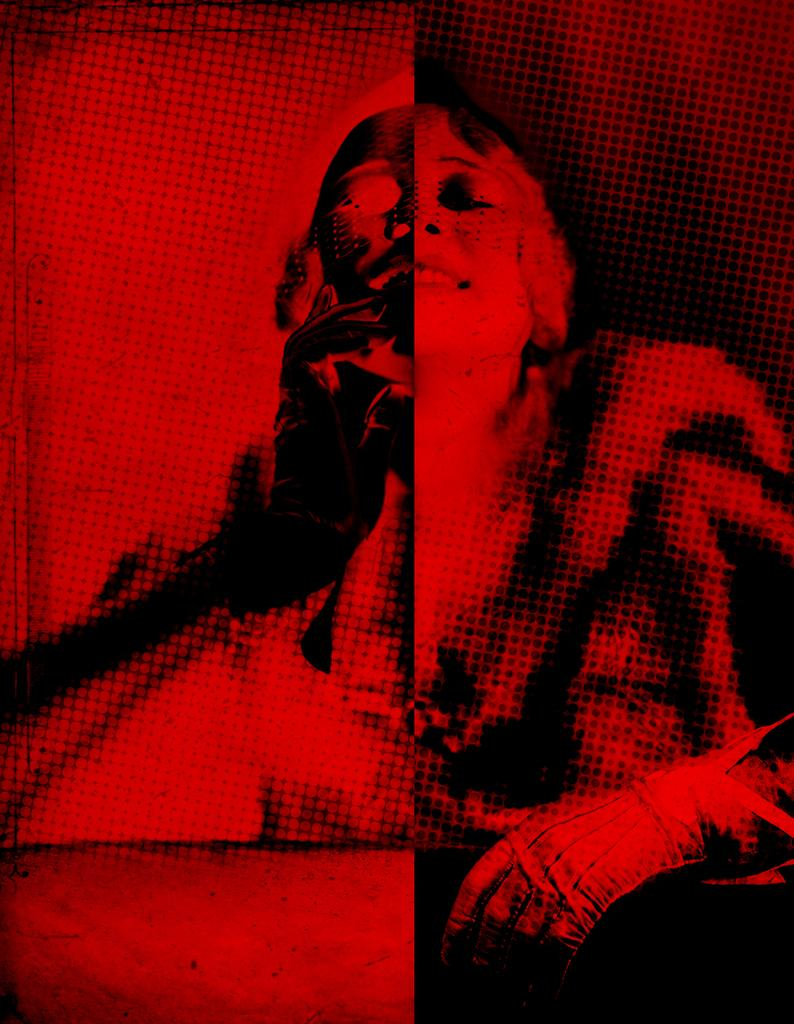What type of image is being described? The image is an edited picture of a person. What colors are predominant in the image? The color of the image is red and black. What type of earth can be seen in the image? There is no earth visible in the image, as it is an edited picture of a person. What is the most attractive feature of the image? The question of attraction is subjective and cannot be definitively answered based on the provided facts. 